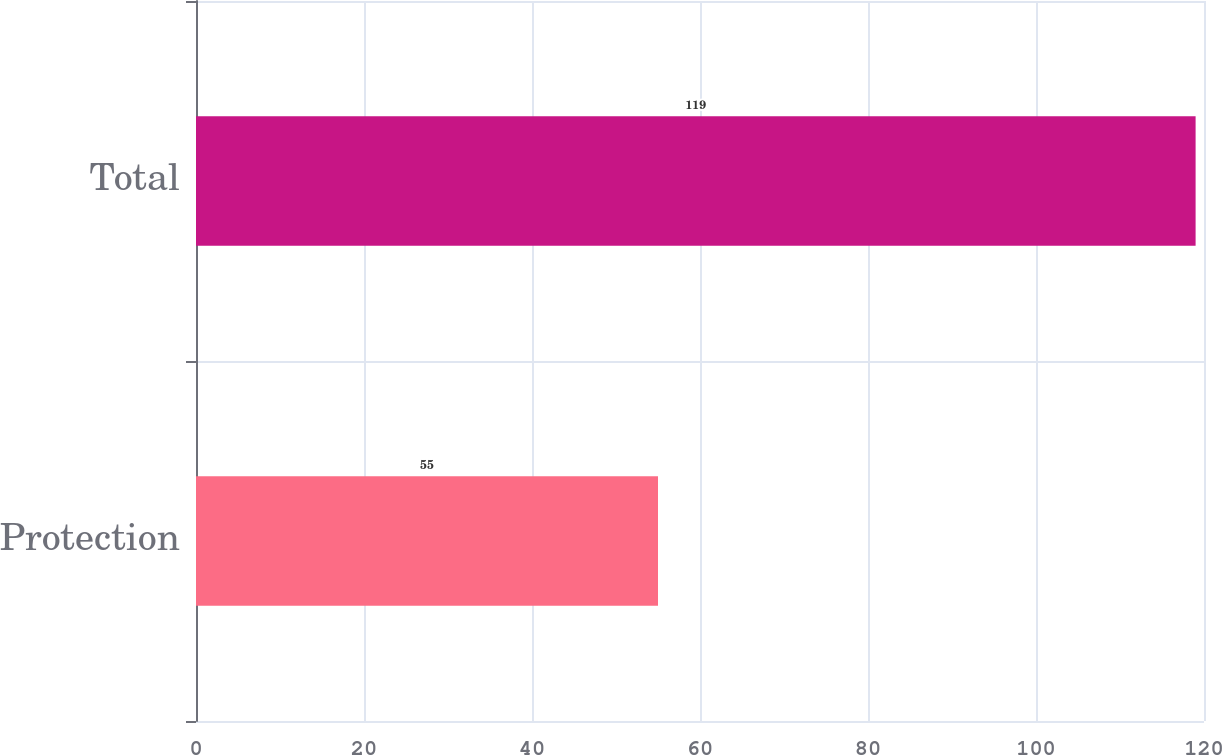Convert chart. <chart><loc_0><loc_0><loc_500><loc_500><bar_chart><fcel>Protection<fcel>Total<nl><fcel>55<fcel>119<nl></chart> 